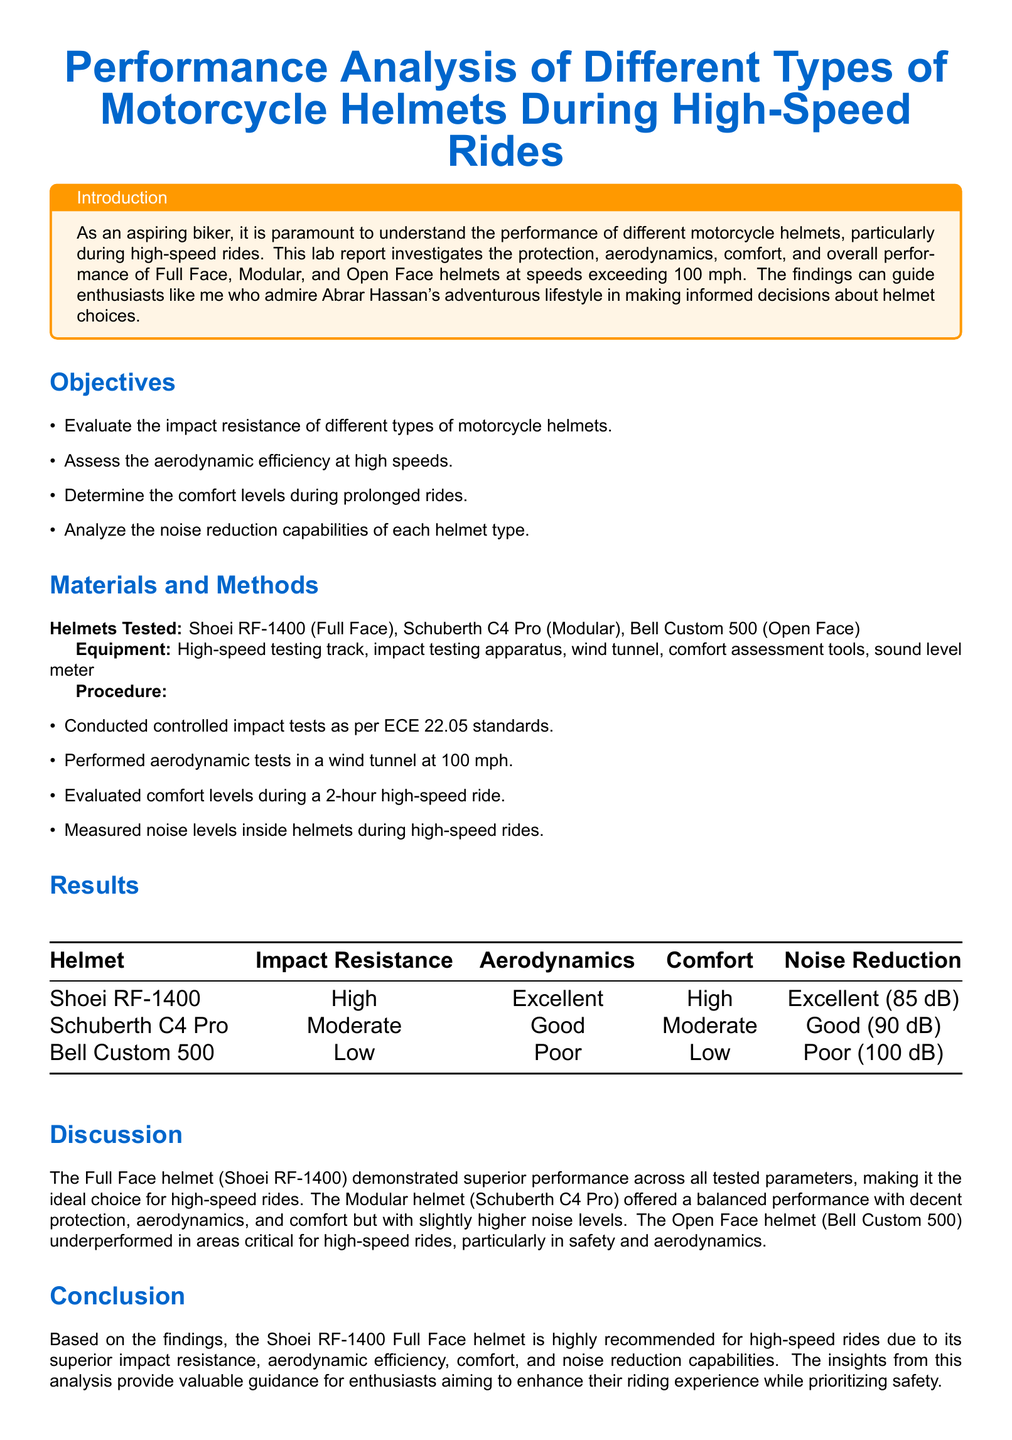what is the title of the lab report? The title of the lab report is provided at the beginning of the document.
Answer: Performance Analysis of Different Types of Motorcycle Helmets During High-Speed Rides what types of helmets were tested? The types of helmets tested are listed in the materials section.
Answer: Full Face, Modular, Open Face which helmet had the highest impact resistance? The impact resistance results are summarized in the results section.
Answer: Shoei RF-1400 what was the noise level measured for the Bell Custom 500 helmet? The noise reduction capabilities are detailed in the results table.
Answer: Poor (100 dB) which helmet offered moderate comfort levels? The comfort levels for each helmet are specified in the results table.
Answer: Schuberth C4 Pro what is the aerodynamic performance of the Shoei RF-1400? The aerodynamic efficiency is reported in the results section for each helmet.
Answer: Excellent which quality was assessed during a 2-hour ride? The procedure section describes the evaluation that took place.
Answer: Comfort what conclusion is drawn about the Shoei RF-1400 helmet? The conclusion summarizes the findings based on the tested parameters.
Answer: Highly recommended for high-speed rides 